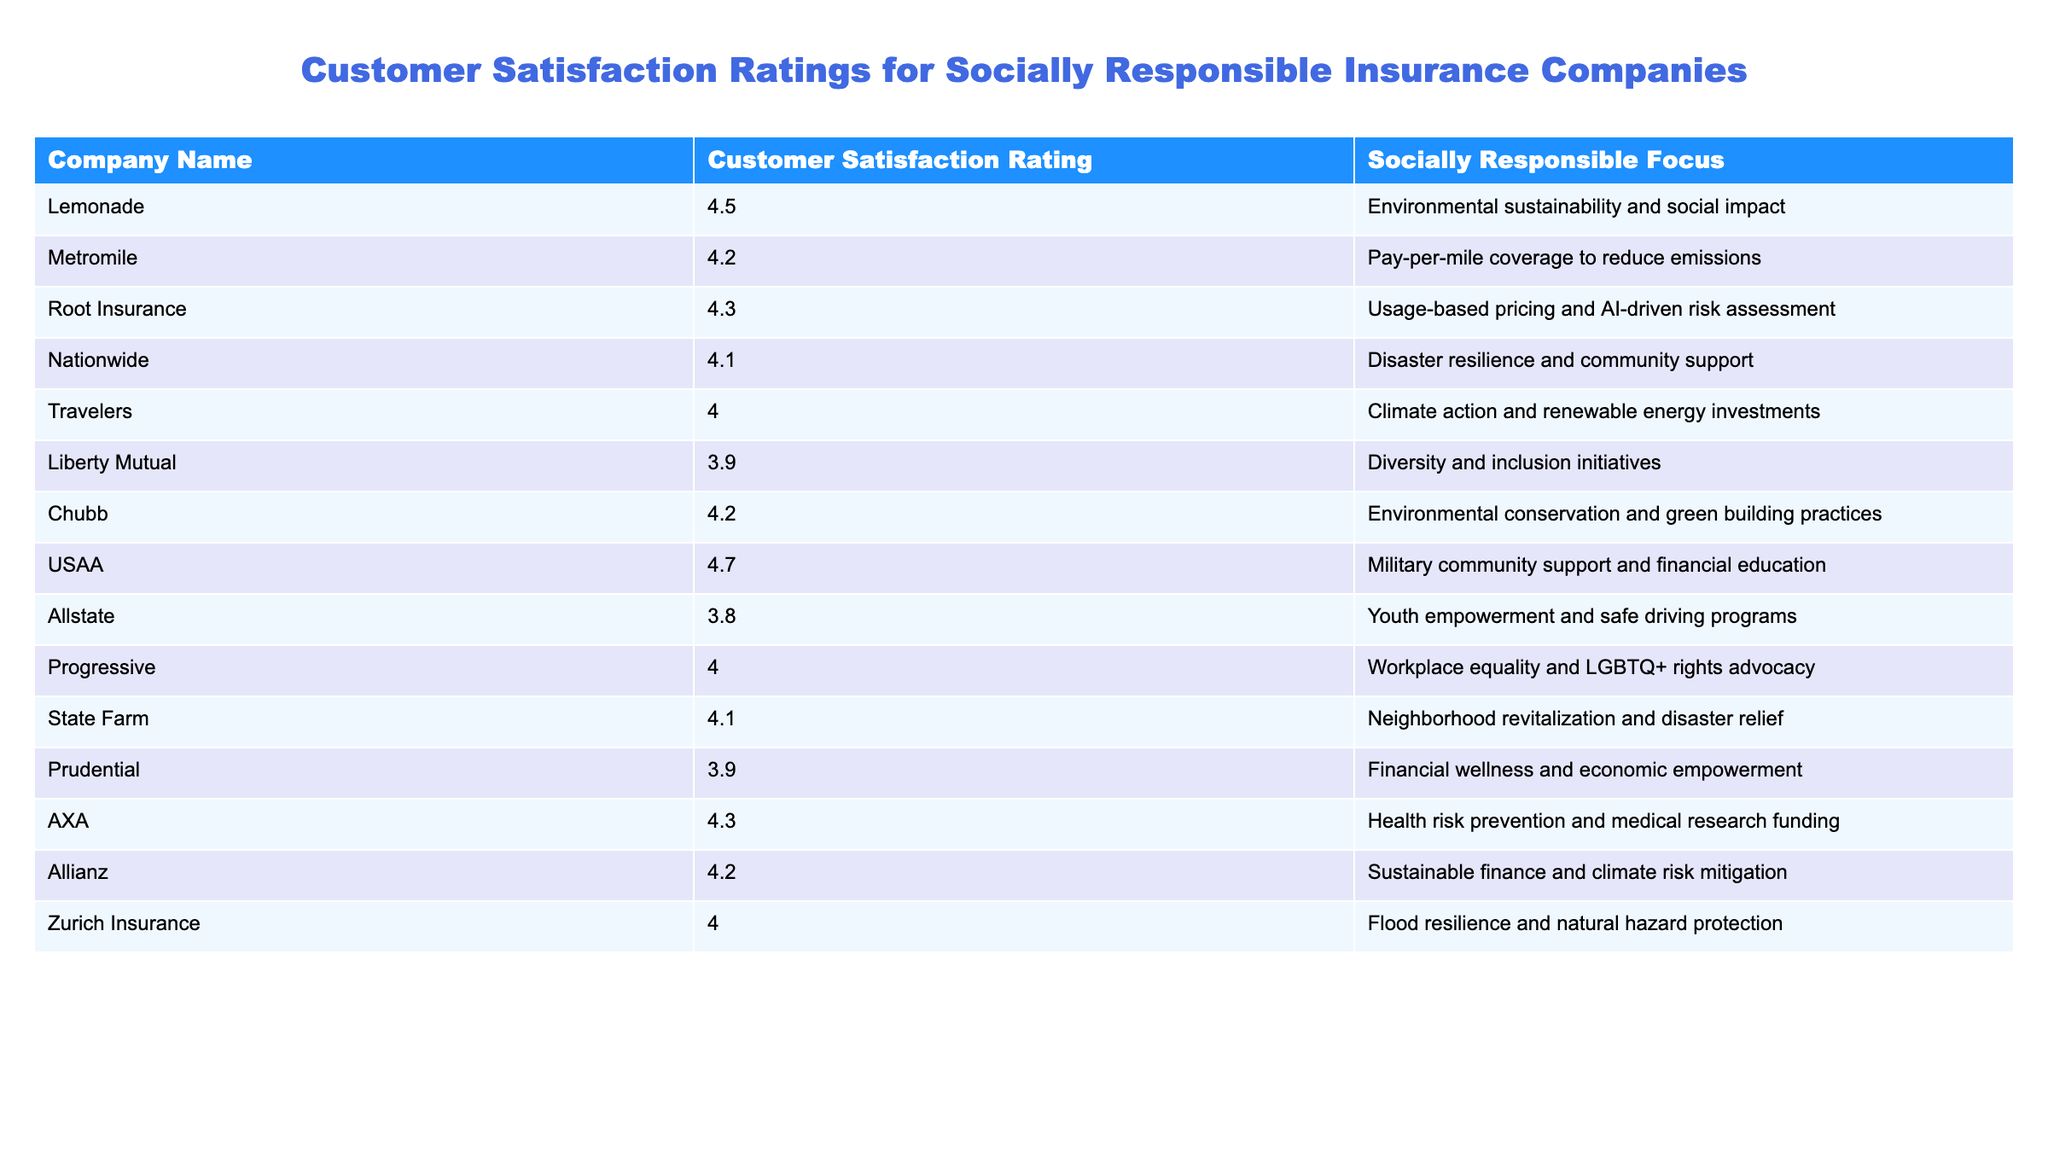What is the customer satisfaction rating for USAA? By looking at the table, the customer satisfaction rating listed next to USAA is 4.7.
Answer: 4.7 Which company has the highest customer satisfaction rating? The highest rating in the table is 4.7, which corresponds to USAA.
Answer: USAA What is the customer satisfaction rating for Liberty Mutual? The table shows that Liberty Mutual has a customer satisfaction rating of 3.9.
Answer: 3.9 Which two companies have the same customer satisfaction rating of 4.2? By checking the table, both Metromile and Allianz have satisfaction ratings of 4.2.
Answer: Metromile and Allianz What is the average customer satisfaction rating of the listed companies? To find the average, we sum all ratings (4.5 + 4.2 + 4.3 + 4.1 + 4.0 + 3.9 + 4.2 + 4.7 + 3.8 + 4.0 + 4.1 + 3.9 + 4.3 + 4.2 + 4.0) = 62.1 and then divide by the number of companies (15), which is 62.1 / 15 = 4.14.
Answer: 4.14 Would you say that the average customer satisfaction rating is above 4.0? Since the average rating calculated is 4.14, which is greater than 4.0, the answer is yes.
Answer: Yes How many companies have customer satisfaction ratings of 4.0 or higher? By counting the ratings equal to or above 4.0, we find that there are 10 companies with ratings at or above this threshold (4.5, 4.2, 4.3, 4.1, 4.0, 4.2, 4.7, 4.0, 4.1, and 4.3).
Answer: 10 What socially responsible focus does Root Insurance have? According to the table, Root Insurance focuses on usage-based pricing and AI-driven risk assessment.
Answer: Usage-based pricing and AI-driven risk assessment Which company has a socially responsible focus related to military community support? The table indicates that USAA focuses on military community support and financial education.
Answer: USAA Is there a company in the table that has a focus on customer disaster resilience? Yes, Nationwide has a focus on disaster resilience and community support as shown in the table.
Answer: Yes Which company has the lowest customer satisfaction rating and what is their focus? The lowest rating is 3.8, associated with Allstate, which focuses on youth empowerment and safe driving programs.
Answer: Allstate, youth empowerment and safe driving programs 